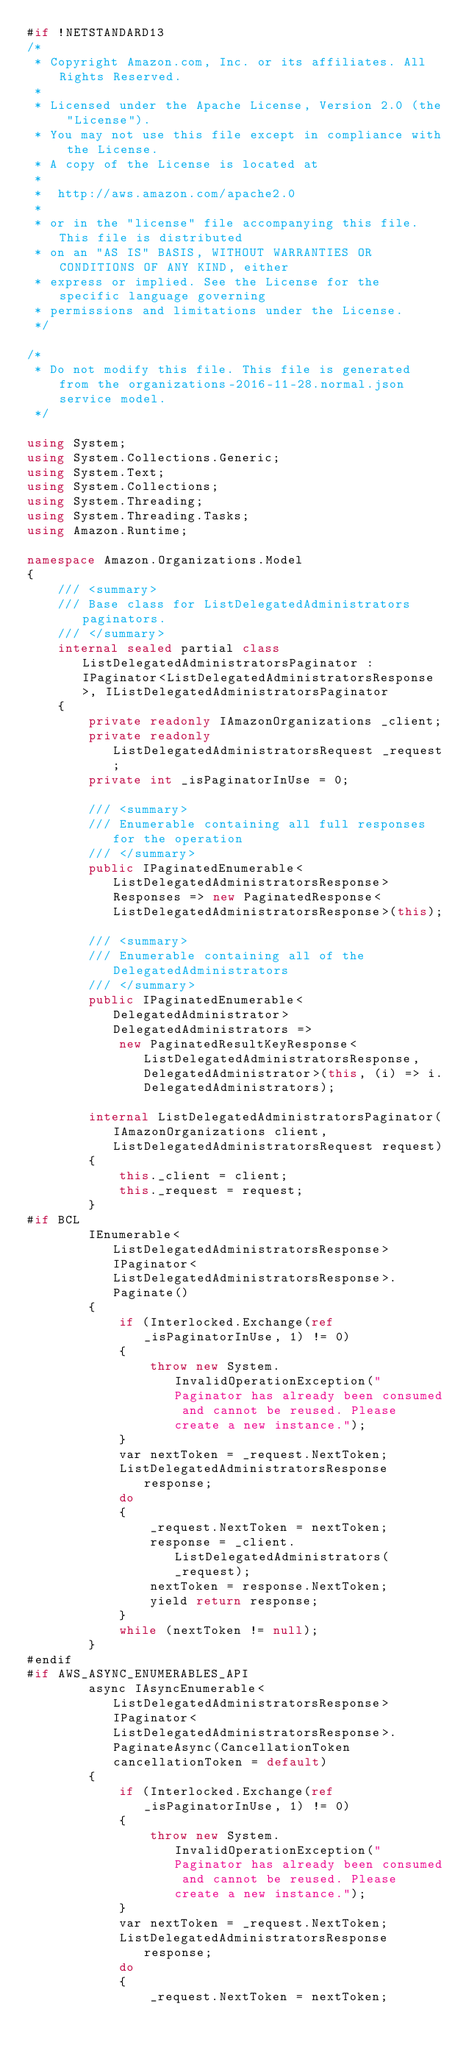Convert code to text. <code><loc_0><loc_0><loc_500><loc_500><_C#_>#if !NETSTANDARD13
/*
 * Copyright Amazon.com, Inc. or its affiliates. All Rights Reserved.
 * 
 * Licensed under the Apache License, Version 2.0 (the "License").
 * You may not use this file except in compliance with the License.
 * A copy of the License is located at
 * 
 *  http://aws.amazon.com/apache2.0
 * 
 * or in the "license" file accompanying this file. This file is distributed
 * on an "AS IS" BASIS, WITHOUT WARRANTIES OR CONDITIONS OF ANY KIND, either
 * express or implied. See the License for the specific language governing
 * permissions and limitations under the License.
 */

/*
 * Do not modify this file. This file is generated from the organizations-2016-11-28.normal.json service model.
 */

using System;
using System.Collections.Generic;
using System.Text;
using System.Collections;
using System.Threading;
using System.Threading.Tasks;
using Amazon.Runtime;
 
namespace Amazon.Organizations.Model
{
    /// <summary>
    /// Base class for ListDelegatedAdministrators paginators.
    /// </summary>
    internal sealed partial class ListDelegatedAdministratorsPaginator : IPaginator<ListDelegatedAdministratorsResponse>, IListDelegatedAdministratorsPaginator
    {
        private readonly IAmazonOrganizations _client;
        private readonly ListDelegatedAdministratorsRequest _request;
        private int _isPaginatorInUse = 0;
        
        /// <summary>
        /// Enumerable containing all full responses for the operation
        /// </summary>
        public IPaginatedEnumerable<ListDelegatedAdministratorsResponse> Responses => new PaginatedResponse<ListDelegatedAdministratorsResponse>(this);

        /// <summary>
        /// Enumerable containing all of the DelegatedAdministrators
        /// </summary>
        public IPaginatedEnumerable<DelegatedAdministrator> DelegatedAdministrators => 
            new PaginatedResultKeyResponse<ListDelegatedAdministratorsResponse, DelegatedAdministrator>(this, (i) => i.DelegatedAdministrators);

        internal ListDelegatedAdministratorsPaginator(IAmazonOrganizations client, ListDelegatedAdministratorsRequest request)
        {
            this._client = client;
            this._request = request;
        }
#if BCL
        IEnumerable<ListDelegatedAdministratorsResponse> IPaginator<ListDelegatedAdministratorsResponse>.Paginate()
        {
            if (Interlocked.Exchange(ref _isPaginatorInUse, 1) != 0)
            {
                throw new System.InvalidOperationException("Paginator has already been consumed and cannot be reused. Please create a new instance.");
            }
            var nextToken = _request.NextToken;
            ListDelegatedAdministratorsResponse response;
            do
            {
                _request.NextToken = nextToken;
                response = _client.ListDelegatedAdministrators(_request);
                nextToken = response.NextToken;
                yield return response;
            }
            while (nextToken != null);
        }
#endif
#if AWS_ASYNC_ENUMERABLES_API
        async IAsyncEnumerable<ListDelegatedAdministratorsResponse> IPaginator<ListDelegatedAdministratorsResponse>.PaginateAsync(CancellationToken cancellationToken = default)
        {
            if (Interlocked.Exchange(ref _isPaginatorInUse, 1) != 0)
            {
                throw new System.InvalidOperationException("Paginator has already been consumed and cannot be reused. Please create a new instance.");
            }
            var nextToken = _request.NextToken;
            ListDelegatedAdministratorsResponse response;
            do
            {
                _request.NextToken = nextToken;</code> 